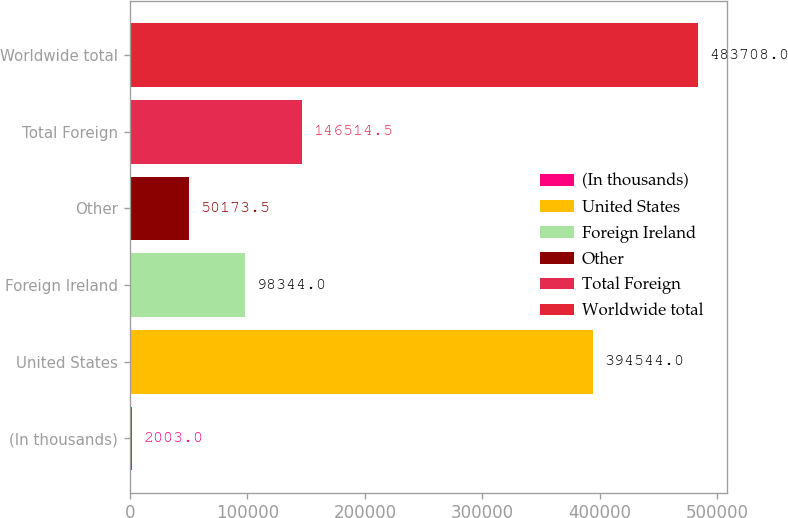Convert chart. <chart><loc_0><loc_0><loc_500><loc_500><bar_chart><fcel>(In thousands)<fcel>United States<fcel>Foreign Ireland<fcel>Other<fcel>Total Foreign<fcel>Worldwide total<nl><fcel>2003<fcel>394544<fcel>98344<fcel>50173.5<fcel>146514<fcel>483708<nl></chart> 